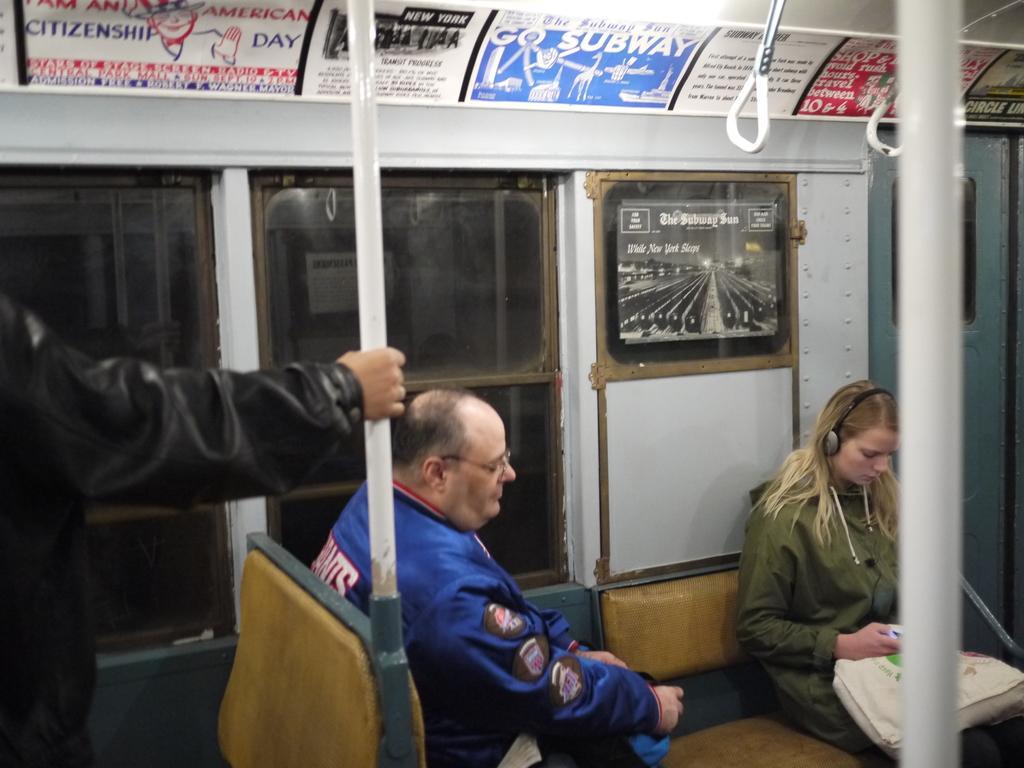How would you summarize this image in a sentence or two? In this picture, it looks like an inside view of a vehicle. There are two people sitting on the seats and a person in the black jacket is standing and holding a rod. In front of the person there are glass windows, supporting handles, a door and boards. 